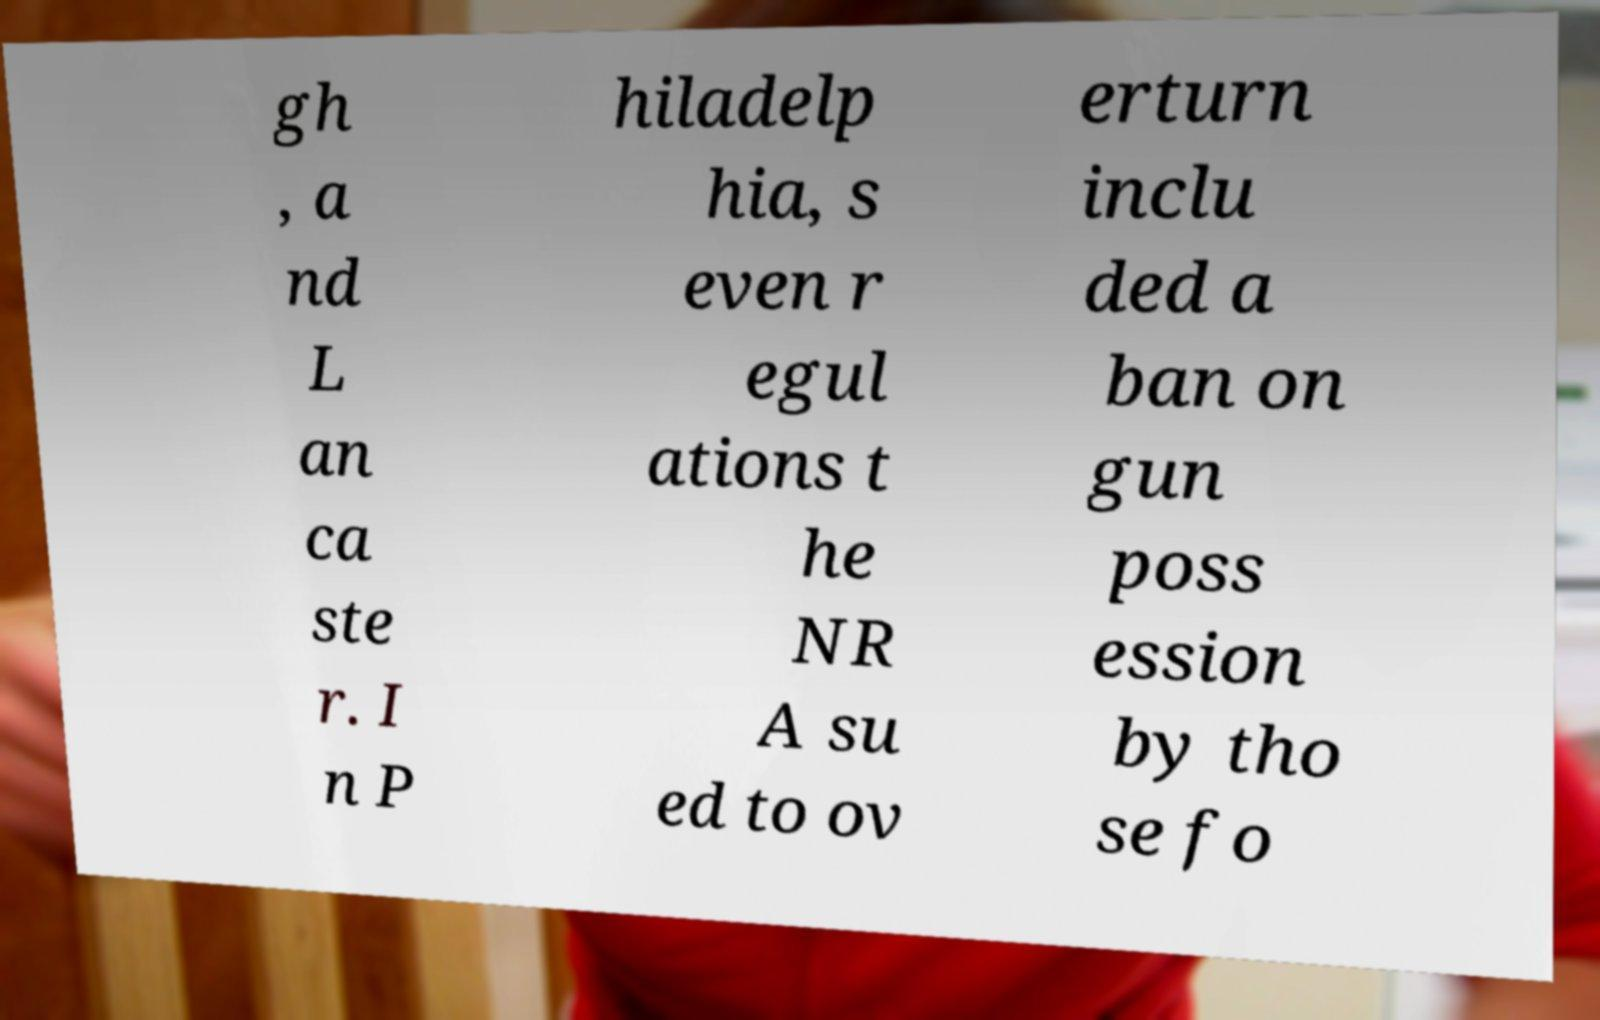For documentation purposes, I need the text within this image transcribed. Could you provide that? gh , a nd L an ca ste r. I n P hiladelp hia, s even r egul ations t he NR A su ed to ov erturn inclu ded a ban on gun poss ession by tho se fo 